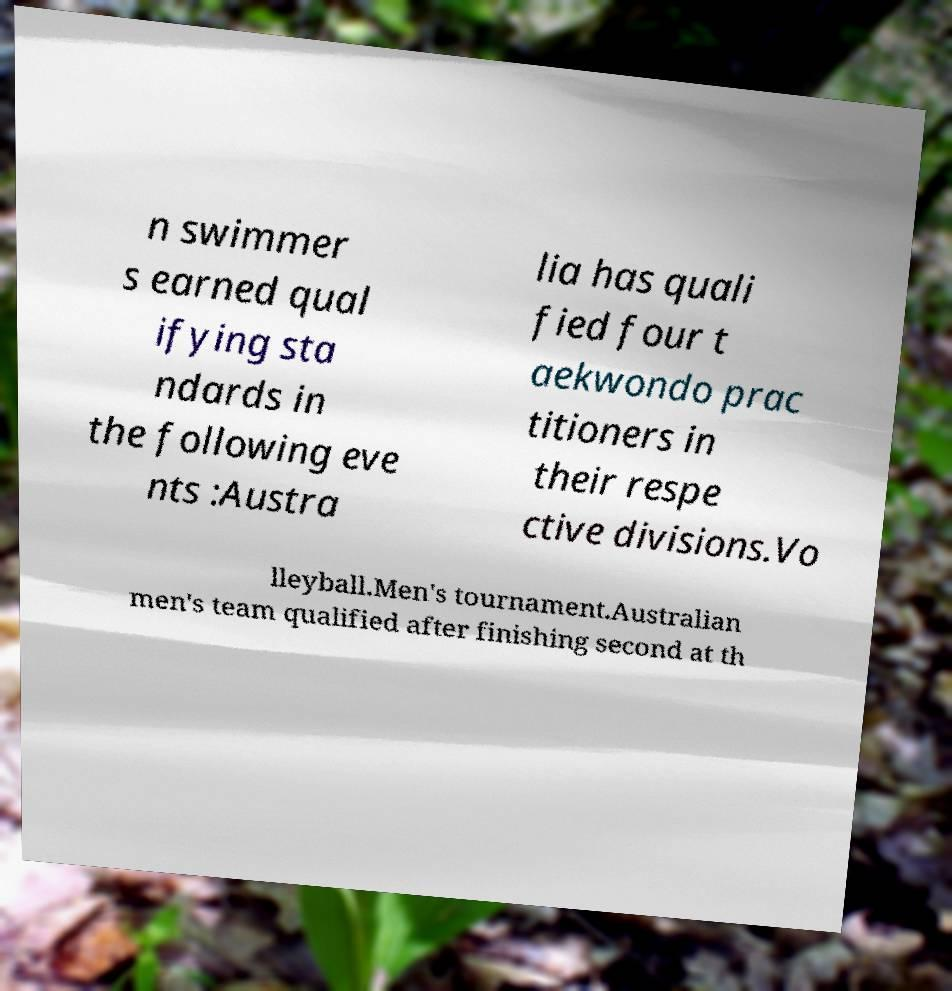What messages or text are displayed in this image? I need them in a readable, typed format. n swimmer s earned qual ifying sta ndards in the following eve nts :Austra lia has quali fied four t aekwondo prac titioners in their respe ctive divisions.Vo lleyball.Men's tournament.Australian men's team qualified after finishing second at th 